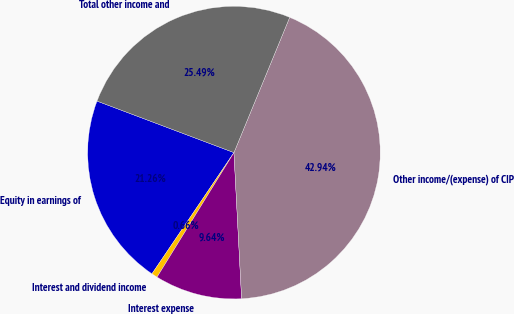Convert chart to OTSL. <chart><loc_0><loc_0><loc_500><loc_500><pie_chart><fcel>Equity in earnings of<fcel>Interest and dividend income<fcel>Interest expense<fcel>Other income/(expense) of CIP<fcel>Total other income and<nl><fcel>21.26%<fcel>0.66%<fcel>9.64%<fcel>42.94%<fcel>25.49%<nl></chart> 